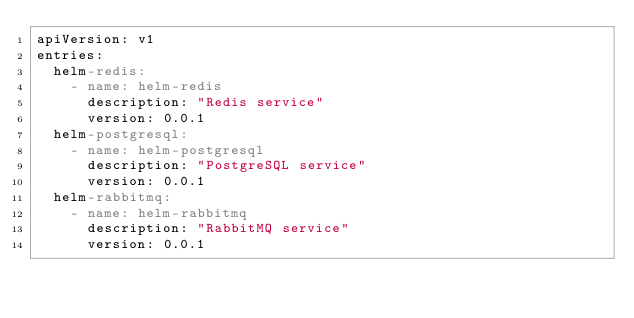Convert code to text. <code><loc_0><loc_0><loc_500><loc_500><_YAML_>apiVersion: v1
entries:
  helm-redis:
    - name: helm-redis
      description: "Redis service"
      version: 0.0.1 
  helm-postgresql:
    - name: helm-postgresql
      description: "PostgreSQL service"
      version: 0.0.1 
  helm-rabbitmq:
    - name: helm-rabbitmq
      description: "RabbitMQ service"
      version: 0.0.1 
</code> 